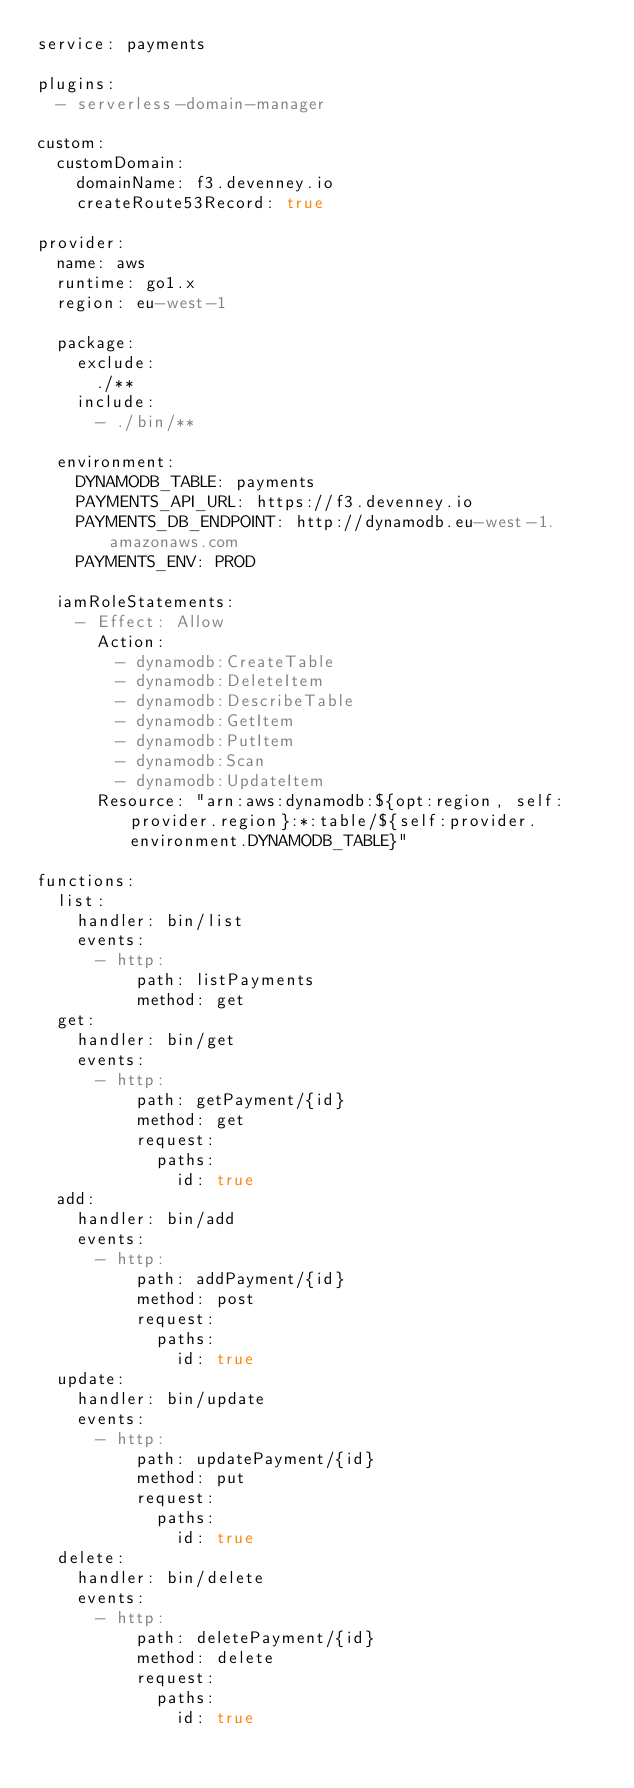Convert code to text. <code><loc_0><loc_0><loc_500><loc_500><_YAML_>service: payments

plugins:
  - serverless-domain-manager

custom:
  customDomain:
    domainName: f3.devenney.io
    createRoute53Record: true

provider:
  name: aws
  runtime: go1.x
  region: eu-west-1

  package:
    exclude:
      ./**
    include:
      - ./bin/**

  environment:
    DYNAMODB_TABLE: payments
    PAYMENTS_API_URL: https://f3.devenney.io
    PAYMENTS_DB_ENDPOINT: http://dynamodb.eu-west-1.amazonaws.com
    PAYMENTS_ENV: PROD

  iamRoleStatements:
    - Effect: Allow
      Action:
        - dynamodb:CreateTable
        - dynamodb:DeleteItem
        - dynamodb:DescribeTable
        - dynamodb:GetItem
        - dynamodb:PutItem
        - dynamodb:Scan
        - dynamodb:UpdateItem
      Resource: "arn:aws:dynamodb:${opt:region, self:provider.region}:*:table/${self:provider.environment.DYNAMODB_TABLE}"

functions:
  list:
    handler: bin/list
    events:
      - http:
          path: listPayments
          method: get
  get:
    handler: bin/get
    events:
      - http:
          path: getPayment/{id}
          method: get
          request:
            paths:
              id: true
  add:
    handler: bin/add
    events:
      - http:
          path: addPayment/{id}
          method: post
          request:
            paths:
              id: true
  update:
    handler: bin/update
    events:
      - http:
          path: updatePayment/{id}
          method: put
          request:
            paths:
              id: true
  delete:
    handler: bin/delete
    events:
      - http:
          path: deletePayment/{id}
          method: delete
          request:
            paths:
              id: true
</code> 